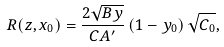<formula> <loc_0><loc_0><loc_500><loc_500>R ( z , x _ { 0 } ) = \frac { 2 \sqrt { B y } } { C A ^ { \prime } } \left ( 1 - y _ { 0 } \right ) \sqrt { C _ { 0 } } ,</formula> 